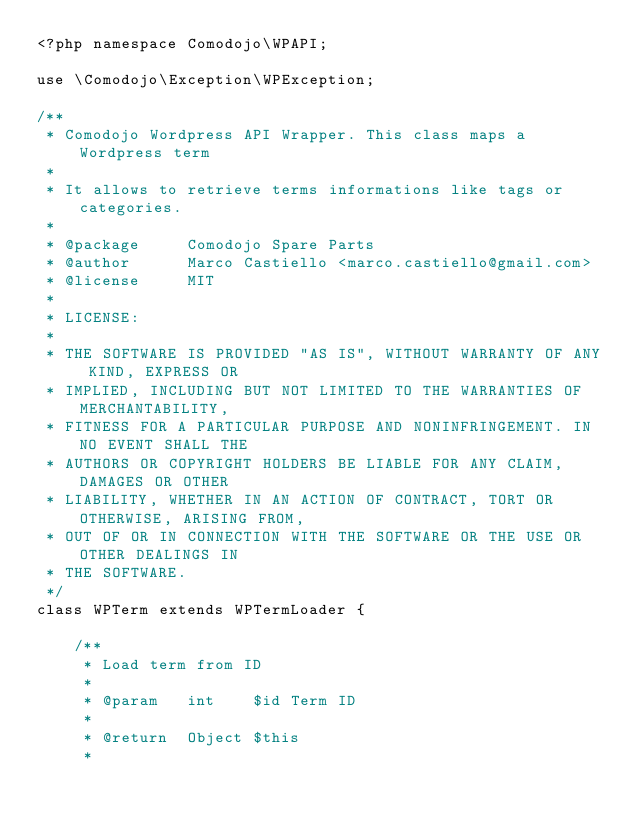<code> <loc_0><loc_0><loc_500><loc_500><_PHP_><?php namespace Comodojo\WPAPI;

use \Comodojo\Exception\WPException;

/** 
 * Comodojo Wordpress API Wrapper. This class maps a Wordpress term
 *
 * It allows to retrieve terms informations like tags or categories.
 * 
 * @package     Comodojo Spare Parts
 * @author      Marco Castiello <marco.castiello@gmail.com>
 * @license     MIT
 *
 * LICENSE:
 * 
 * THE SOFTWARE IS PROVIDED "AS IS", WITHOUT WARRANTY OF ANY KIND, EXPRESS OR
 * IMPLIED, INCLUDING BUT NOT LIMITED TO THE WARRANTIES OF MERCHANTABILITY,
 * FITNESS FOR A PARTICULAR PURPOSE AND NONINFRINGEMENT. IN NO EVENT SHALL THE
 * AUTHORS OR COPYRIGHT HOLDERS BE LIABLE FOR ANY CLAIM, DAMAGES OR OTHER
 * LIABILITY, WHETHER IN AN ACTION OF CONTRACT, TORT OR OTHERWISE, ARISING FROM,
 * OUT OF OR IN CONNECTION WITH THE SOFTWARE OR THE USE OR OTHER DEALINGS IN
 * THE SOFTWARE.
 */
class WPTerm extends WPTermLoader {
	
    /**
     * Load term from ID
     *
     * @param   int    $id Term ID
     *
     * @return  Object $this
     * </code> 